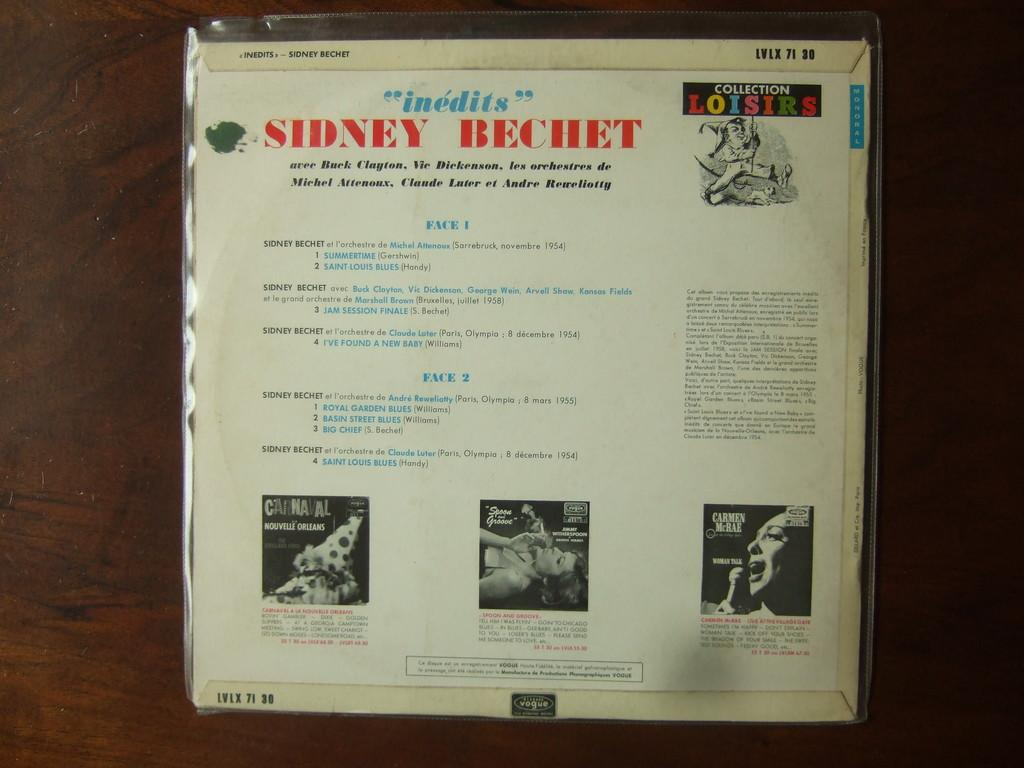Provide a one-sentence caption for the provided image. The back of a package item has things such as SIdney Bechet listed on it. 